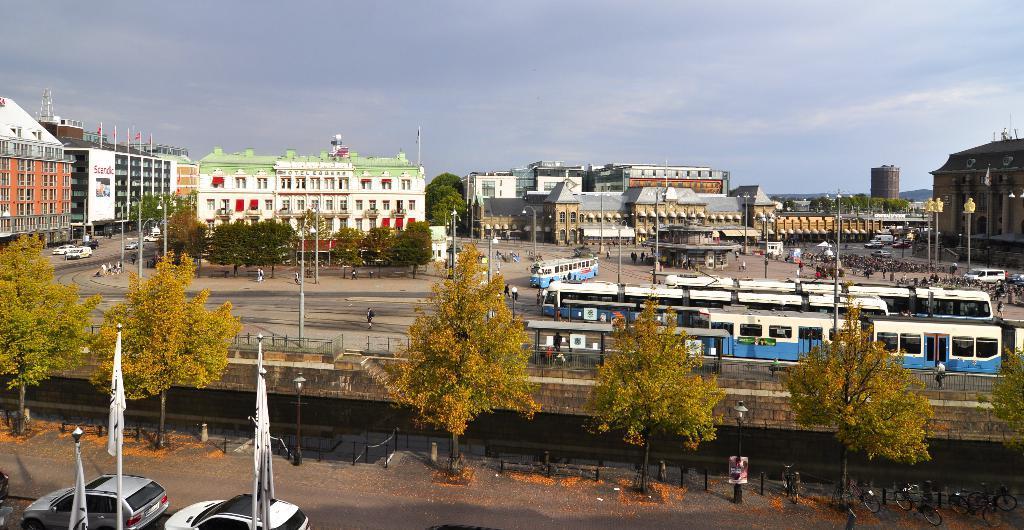Please provide a concise description of this image. Here we can see flags with poles and we can see cars,bicycles,trees and fence. Background we can see people,vehicles,trees,buildings and sky. 